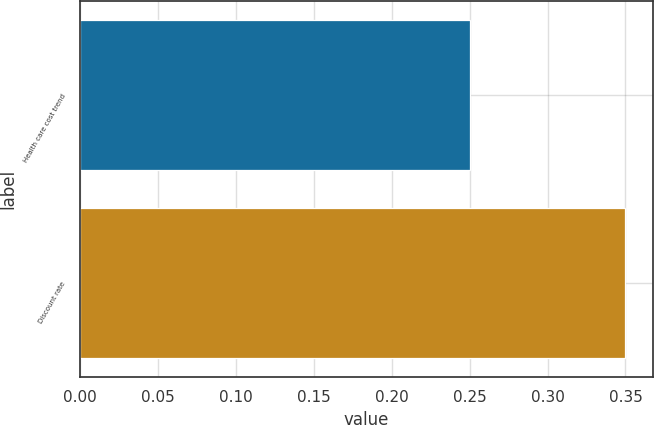Convert chart. <chart><loc_0><loc_0><loc_500><loc_500><bar_chart><fcel>Health care cost trend<fcel>Discount rate<nl><fcel>0.25<fcel>0.35<nl></chart> 